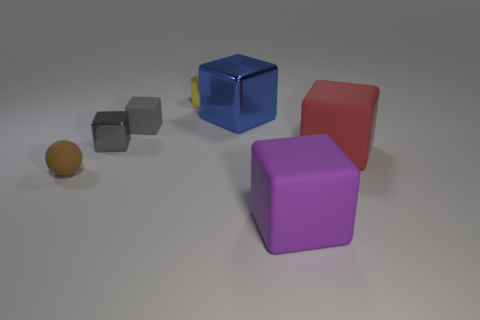Does the small metallic thing that is in front of the yellow shiny cylinder have the same shape as the red rubber thing?
Your answer should be compact. Yes. Are there more blocks on the right side of the large purple rubber object than small green spheres?
Give a very brief answer. Yes. There is a shiny thing in front of the large blue metallic cube; is it the same color as the tiny rubber block?
Provide a short and direct response. Yes. Is there anything else that is the same color as the small metal cylinder?
Your response must be concise. No. There is a shiny cube on the left side of the shiny thing behind the big thing that is behind the gray metallic thing; what color is it?
Offer a terse response. Gray. Does the brown rubber ball have the same size as the yellow cylinder?
Offer a terse response. Yes. What number of other red objects are the same size as the red rubber object?
Your response must be concise. 0. What shape is the tiny shiny thing that is the same color as the tiny matte block?
Offer a very short reply. Cube. Are the tiny gray block that is in front of the tiny gray matte block and the block to the right of the purple rubber object made of the same material?
Provide a short and direct response. No. Is there anything else that is the same shape as the brown matte object?
Make the answer very short. No. 